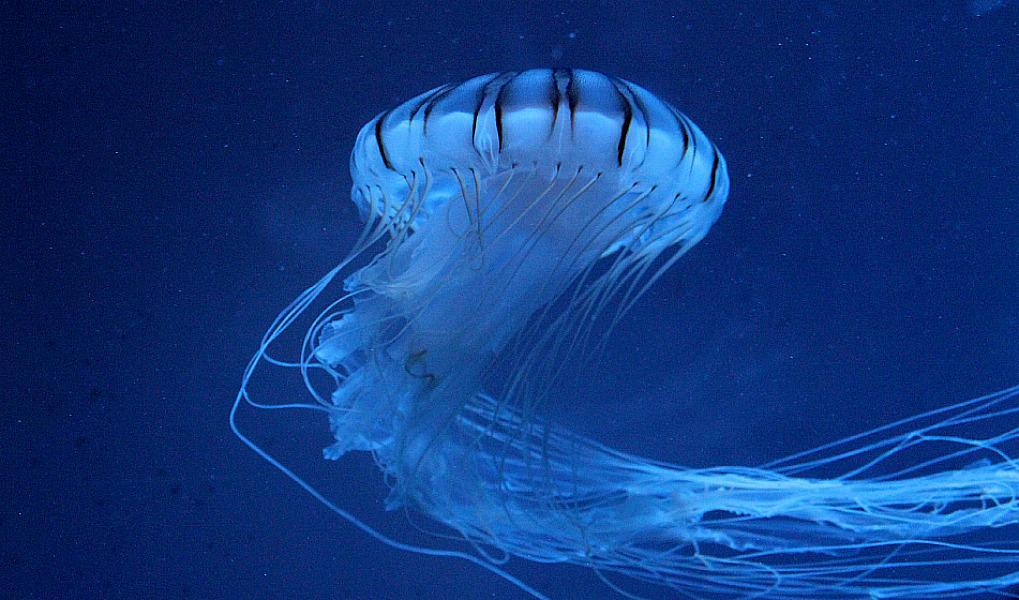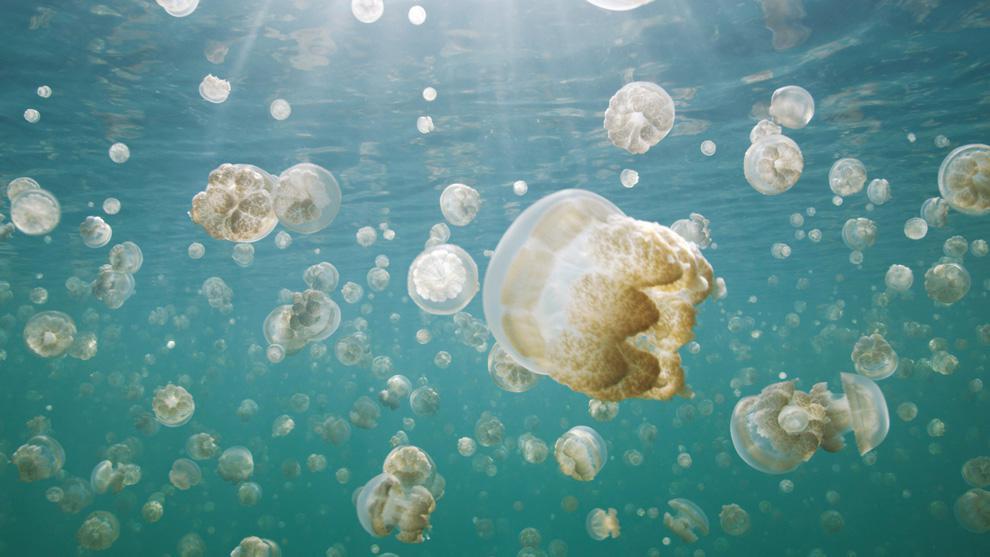The first image is the image on the left, the second image is the image on the right. For the images displayed, is the sentence "There is at least one person in the image on the right" factually correct? Answer yes or no. No. 